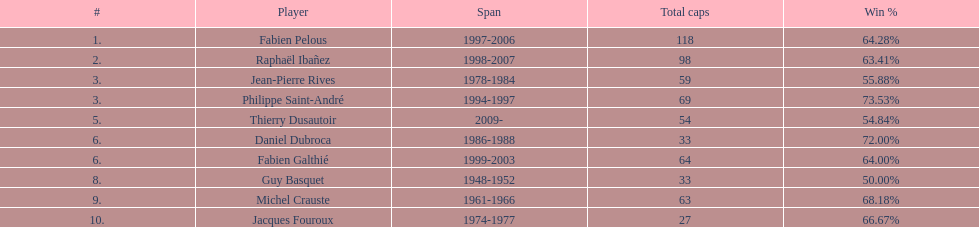How many players have spans above three years? 6. 